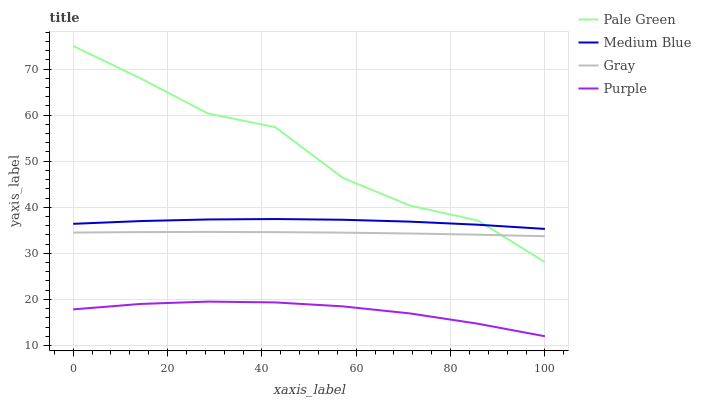Does Purple have the minimum area under the curve?
Answer yes or no. Yes. Does Pale Green have the maximum area under the curve?
Answer yes or no. Yes. Does Gray have the minimum area under the curve?
Answer yes or no. No. Does Gray have the maximum area under the curve?
Answer yes or no. No. Is Gray the smoothest?
Answer yes or no. Yes. Is Pale Green the roughest?
Answer yes or no. Yes. Is Pale Green the smoothest?
Answer yes or no. No. Is Gray the roughest?
Answer yes or no. No. Does Purple have the lowest value?
Answer yes or no. Yes. Does Gray have the lowest value?
Answer yes or no. No. Does Pale Green have the highest value?
Answer yes or no. Yes. Does Gray have the highest value?
Answer yes or no. No. Is Purple less than Pale Green?
Answer yes or no. Yes. Is Gray greater than Purple?
Answer yes or no. Yes. Does Gray intersect Pale Green?
Answer yes or no. Yes. Is Gray less than Pale Green?
Answer yes or no. No. Is Gray greater than Pale Green?
Answer yes or no. No. Does Purple intersect Pale Green?
Answer yes or no. No. 